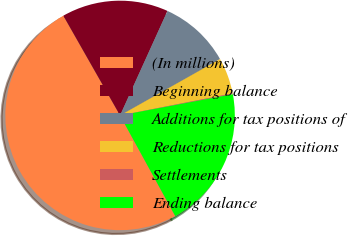<chart> <loc_0><loc_0><loc_500><loc_500><pie_chart><fcel>(In millions)<fcel>Beginning balance<fcel>Additions for tax positions of<fcel>Reductions for tax positions<fcel>Settlements<fcel>Ending balance<nl><fcel>49.75%<fcel>15.01%<fcel>10.05%<fcel>5.09%<fcel>0.12%<fcel>19.98%<nl></chart> 